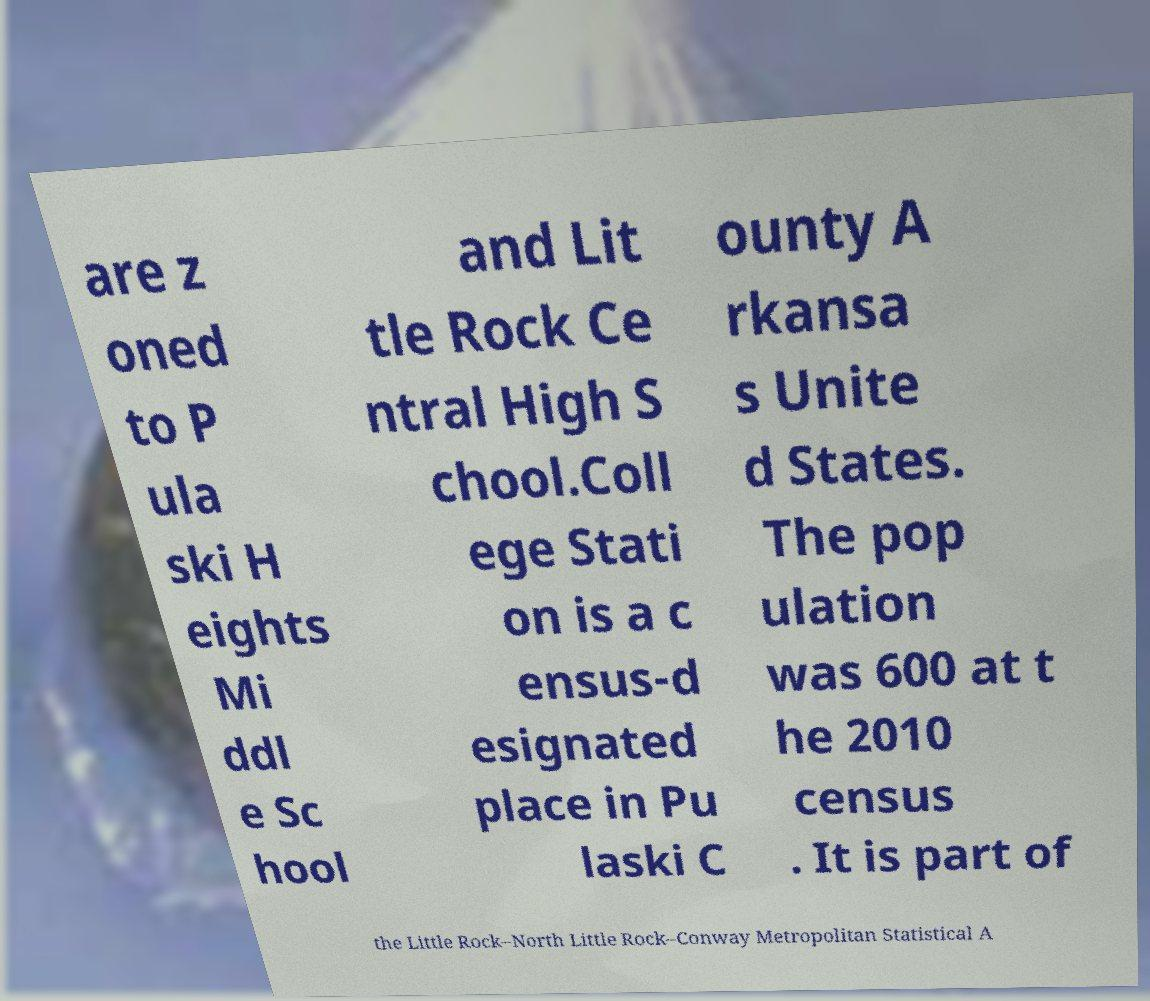Can you accurately transcribe the text from the provided image for me? are z oned to P ula ski H eights Mi ddl e Sc hool and Lit tle Rock Ce ntral High S chool.Coll ege Stati on is a c ensus-d esignated place in Pu laski C ounty A rkansa s Unite d States. The pop ulation was 600 at t he 2010 census . It is part of the Little Rock–North Little Rock–Conway Metropolitan Statistical A 